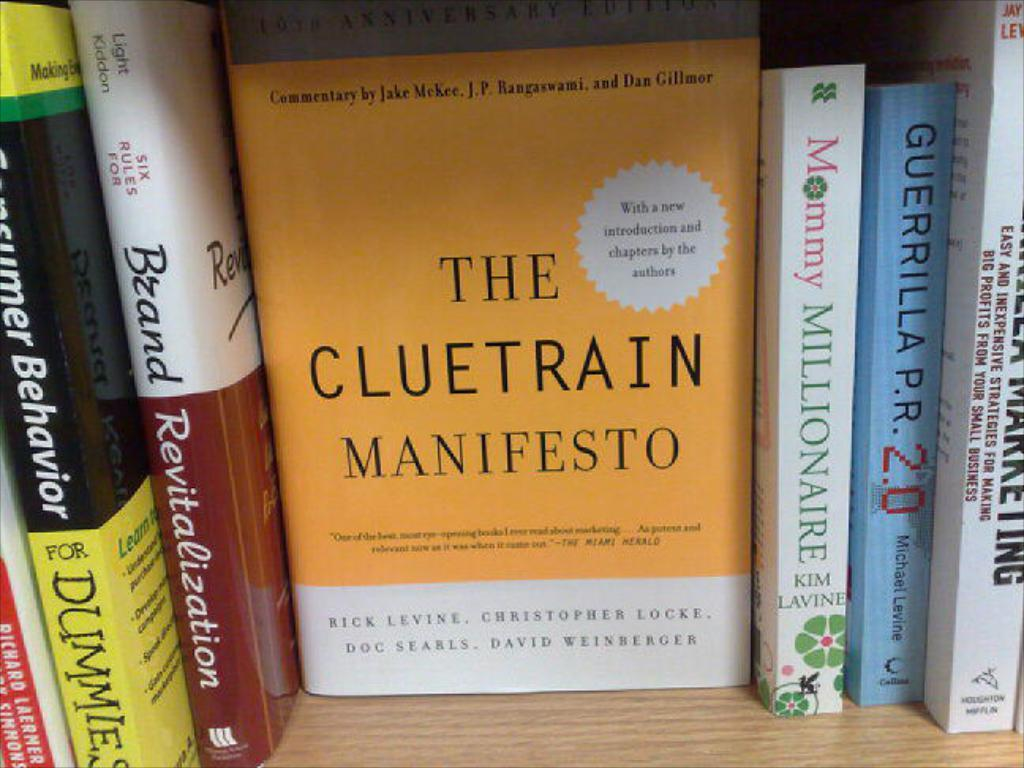<image>
Write a terse but informative summary of the picture. a shelf of books including Mommy Millionaire and Brand Revitalization 